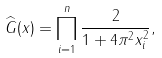<formula> <loc_0><loc_0><loc_500><loc_500>\widehat { G } ( x ) = \prod _ { i = 1 } ^ { n } \frac { 2 } { 1 + 4 \pi ^ { 2 } x _ { i } ^ { 2 } } ,</formula> 